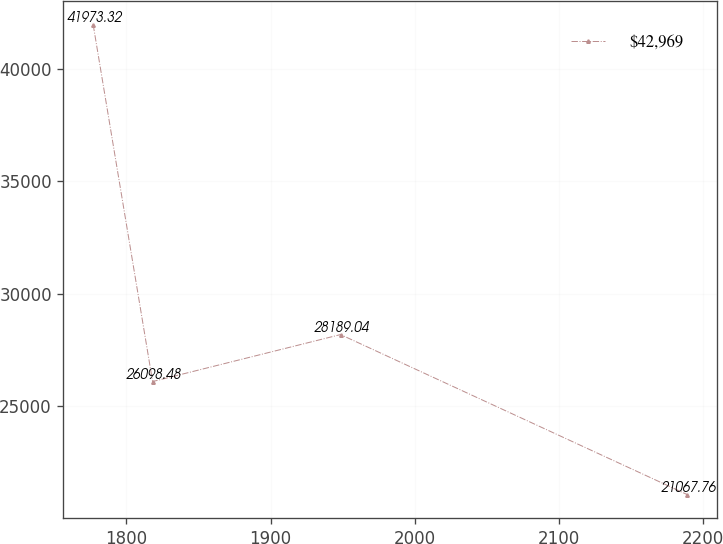<chart> <loc_0><loc_0><loc_500><loc_500><line_chart><ecel><fcel>$42,969<nl><fcel>1776.93<fcel>41973.3<nl><fcel>1818.13<fcel>26098.5<nl><fcel>1948.49<fcel>28189<nl><fcel>2188.97<fcel>21067.8<nl></chart> 